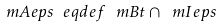Convert formula to latex. <formula><loc_0><loc_0><loc_500><loc_500>\ m A e p s \ e q d e f \ m B t \cap \ m I e p s</formula> 